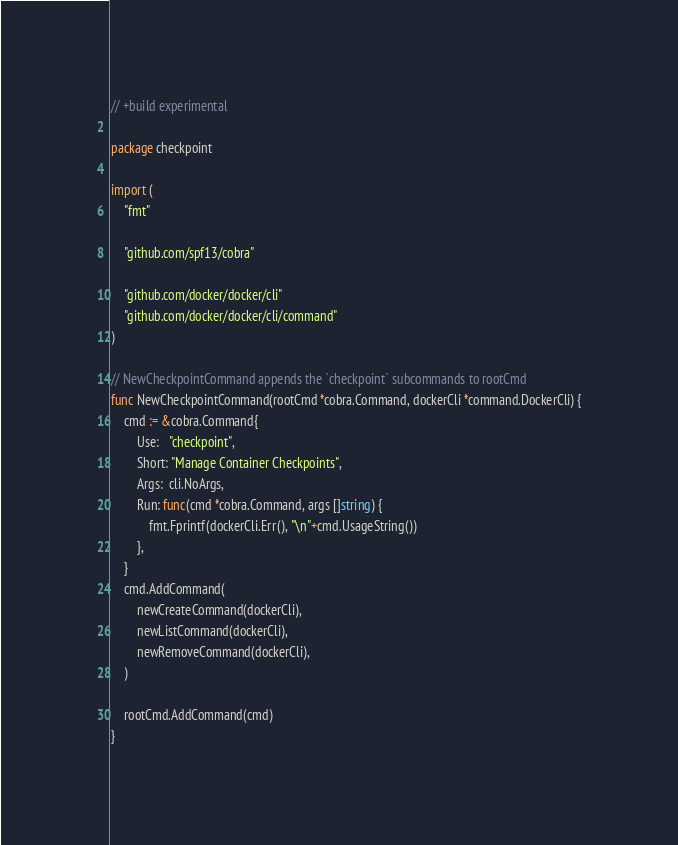Convert code to text. <code><loc_0><loc_0><loc_500><loc_500><_Go_>// +build experimental

package checkpoint

import (
	"fmt"

	"github.com/spf13/cobra"

	"github.com/docker/docker/cli"
	"github.com/docker/docker/cli/command"
)

// NewCheckpointCommand appends the `checkpoint` subcommands to rootCmd
func NewCheckpointCommand(rootCmd *cobra.Command, dockerCli *command.DockerCli) {
	cmd := &cobra.Command{
		Use:   "checkpoint",
		Short: "Manage Container Checkpoints",
		Args:  cli.NoArgs,
		Run: func(cmd *cobra.Command, args []string) {
			fmt.Fprintf(dockerCli.Err(), "\n"+cmd.UsageString())
		},
	}
	cmd.AddCommand(
		newCreateCommand(dockerCli),
		newListCommand(dockerCli),
		newRemoveCommand(dockerCli),
	)

	rootCmd.AddCommand(cmd)
}
</code> 